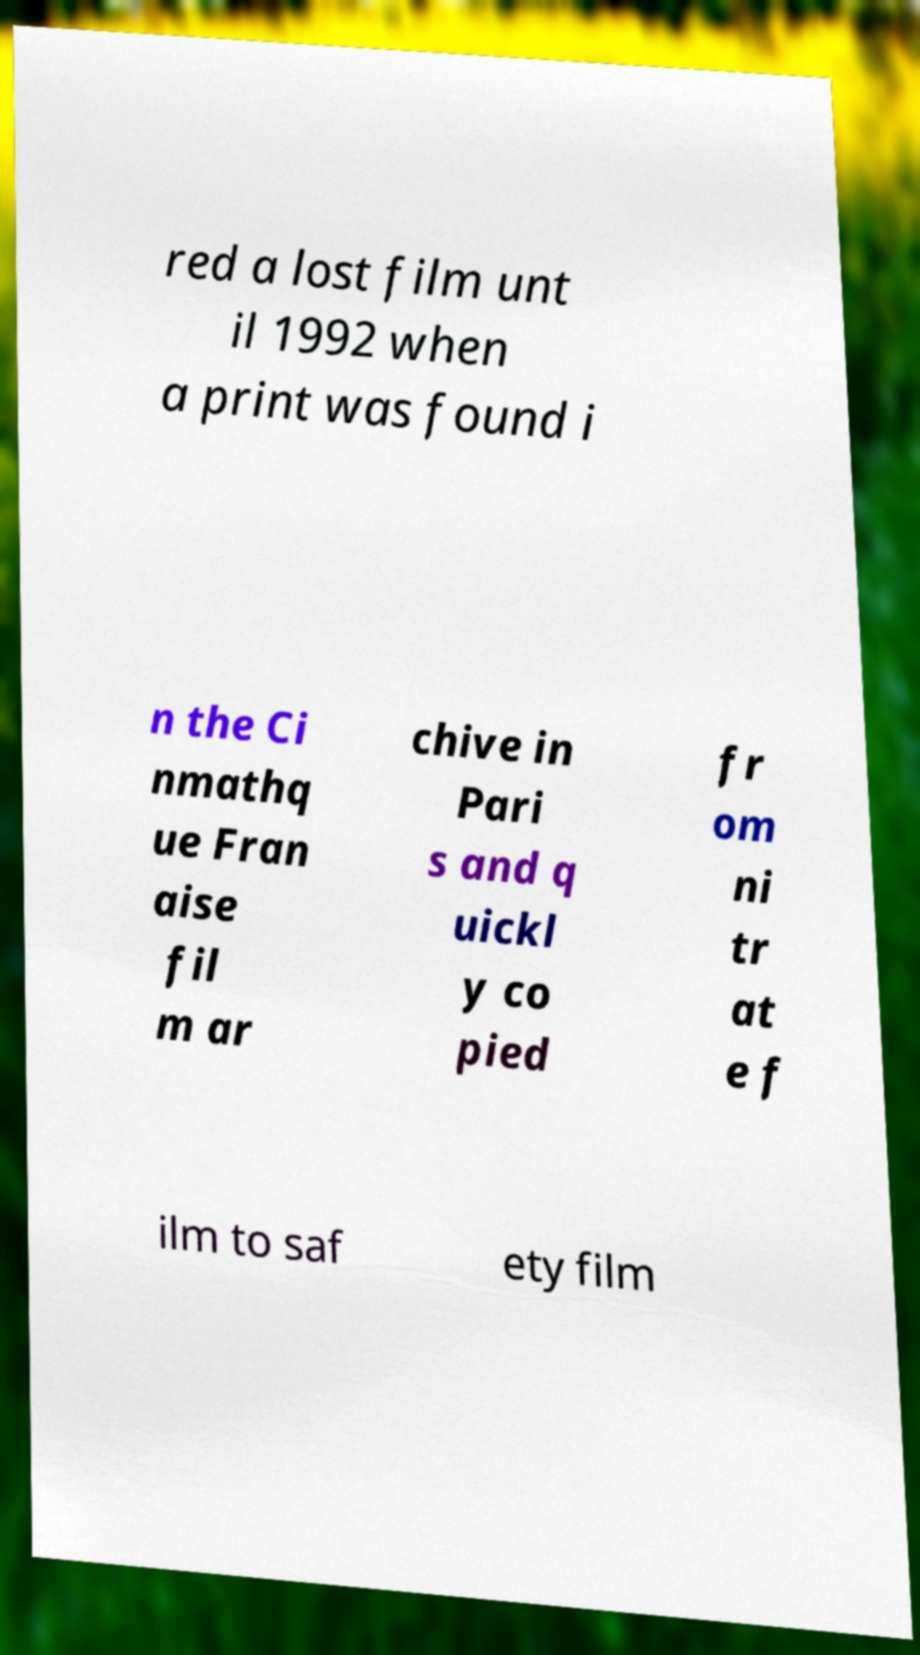Could you assist in decoding the text presented in this image and type it out clearly? red a lost film unt il 1992 when a print was found i n the Ci nmathq ue Fran aise fil m ar chive in Pari s and q uickl y co pied fr om ni tr at e f ilm to saf ety film 